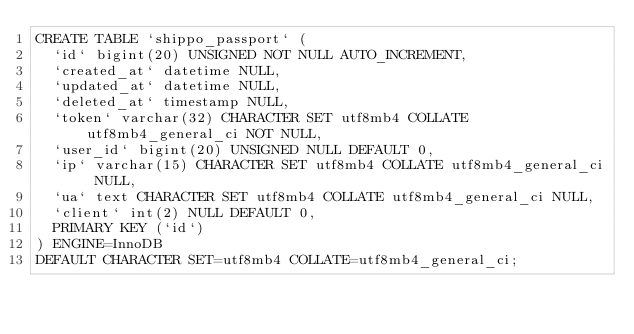<code> <loc_0><loc_0><loc_500><loc_500><_SQL_>CREATE TABLE `shippo_passport` (
	`id` bigint(20) UNSIGNED NOT NULL AUTO_INCREMENT,
	`created_at` datetime NULL,
	`updated_at` datetime NULL,
	`deleted_at` timestamp NULL,
	`token` varchar(32) CHARACTER SET utf8mb4 COLLATE utf8mb4_general_ci NOT NULL,
	`user_id` bigint(20) UNSIGNED NULL DEFAULT 0,
	`ip` varchar(15) CHARACTER SET utf8mb4 COLLATE utf8mb4_general_ci NULL,
	`ua` text CHARACTER SET utf8mb4 COLLATE utf8mb4_general_ci NULL,
	`client` int(2) NULL DEFAULT 0,
	PRIMARY KEY (`id`)
) ENGINE=InnoDB
DEFAULT CHARACTER SET=utf8mb4 COLLATE=utf8mb4_general_ci;</code> 